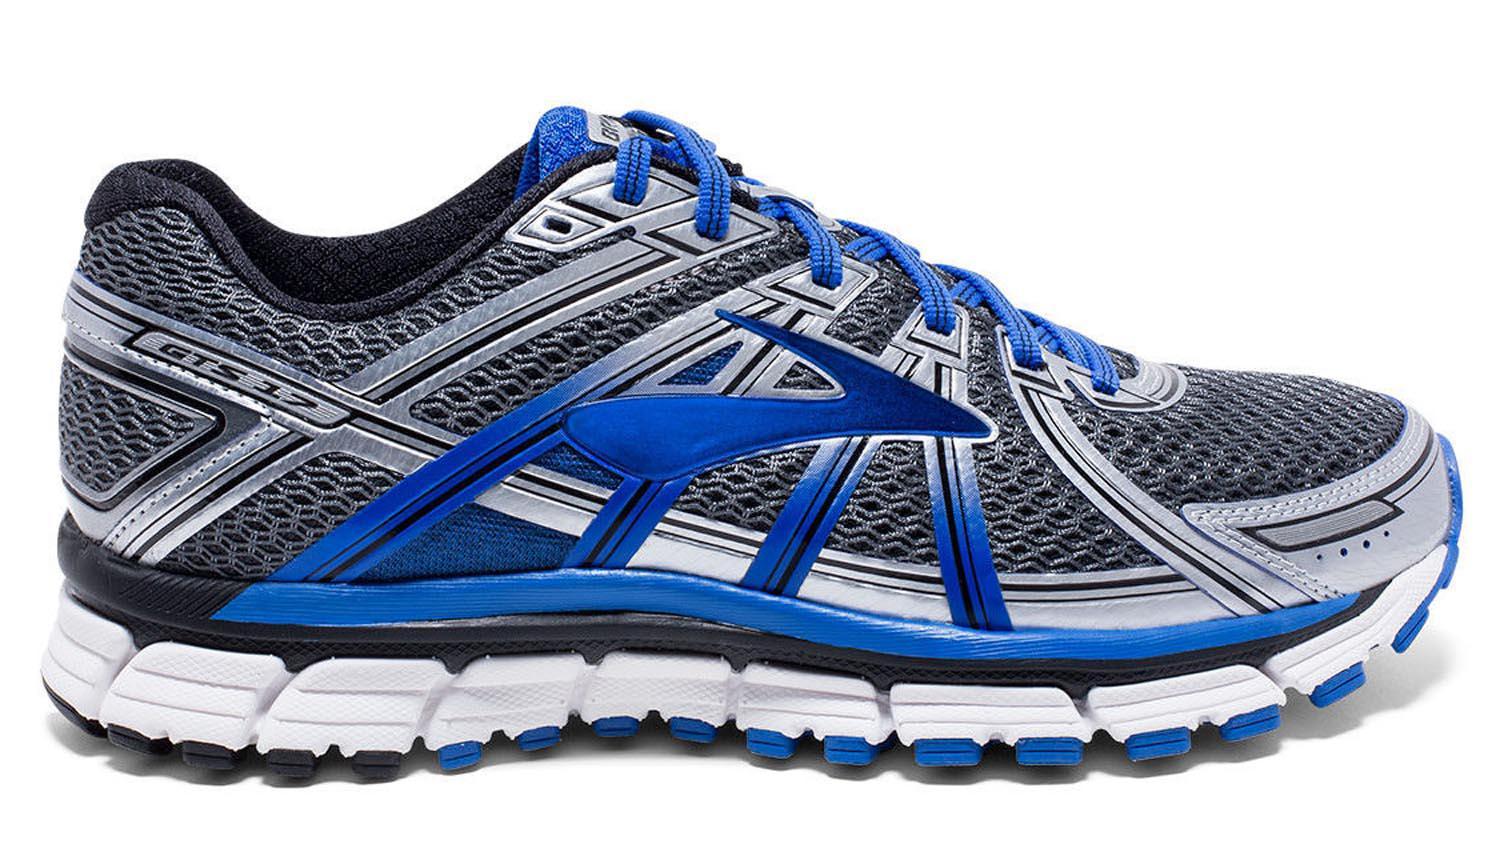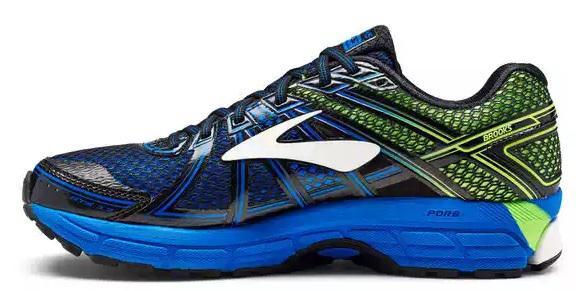The first image is the image on the left, the second image is the image on the right. Assess this claim about the two images: "All shoes pictured are facing rightward.". Correct or not? Answer yes or no. No. The first image is the image on the left, the second image is the image on the right. Analyze the images presented: Is the assertion "There is at least one sneaker that is mainly gray and has blue laces." valid? Answer yes or no. Yes. 